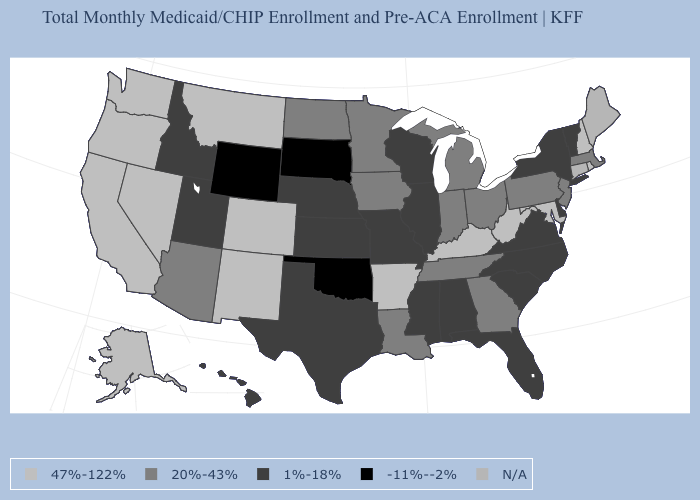What is the value of Oregon?
Concise answer only. 47%-122%. Is the legend a continuous bar?
Give a very brief answer. No. What is the value of New Hampshire?
Be succinct. 47%-122%. What is the value of Georgia?
Keep it brief. 20%-43%. What is the value of Colorado?
Answer briefly. 47%-122%. Name the states that have a value in the range -11%--2%?
Concise answer only. Oklahoma, South Dakota, Wyoming. Among the states that border Ohio , does Indiana have the highest value?
Be succinct. No. Which states have the lowest value in the USA?
Write a very short answer. Oklahoma, South Dakota, Wyoming. What is the value of Maryland?
Give a very brief answer. 47%-122%. Is the legend a continuous bar?
Answer briefly. No. Does the map have missing data?
Quick response, please. Yes. How many symbols are there in the legend?
Concise answer only. 5. What is the lowest value in the USA?
Give a very brief answer. -11%--2%. What is the highest value in the USA?
Short answer required. 47%-122%. 